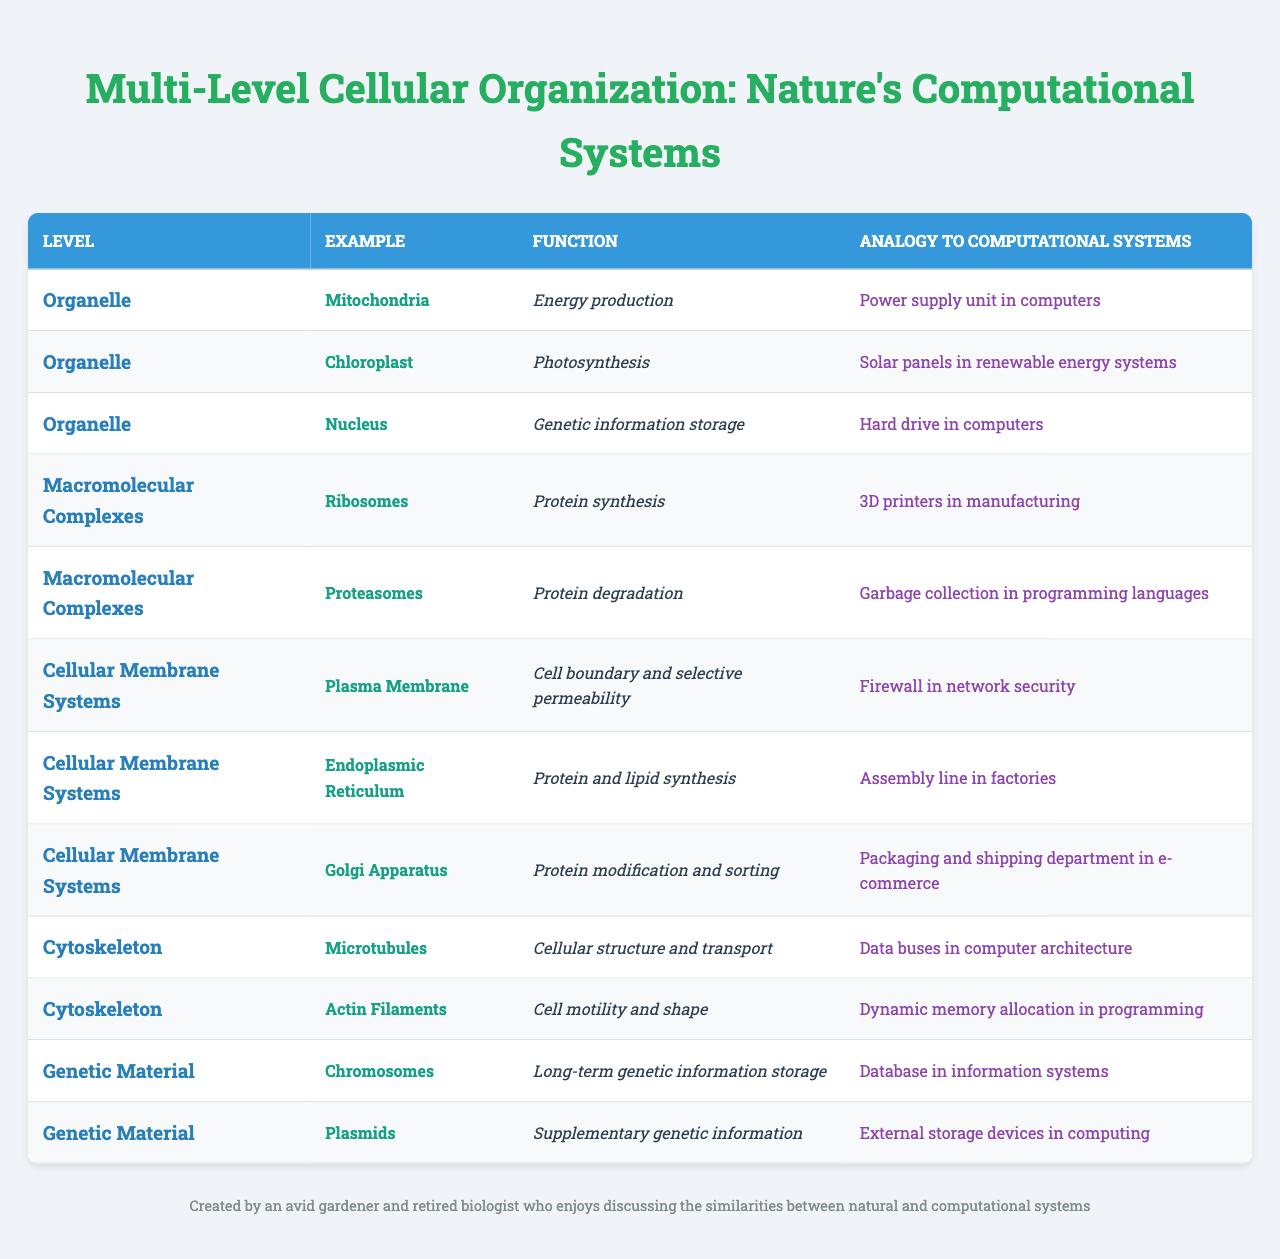What is the function of Ribosomes? Ribosomes are responsible for protein synthesis, as indicated in the table under the macromolecular complexes level.
Answer: Protein synthesis What analogy is used to describe the Chloroplast? The table indicates that Chloroplasts are likened to solar panels in renewable energy systems, which reflects their role in photosynthesis.
Answer: Solar panels in renewable energy systems Are Proteasomes involved in energy production? According to the table, Proteasomes are responsible for protein degradation, not energy production. Therefore, the answer is no.
Answer: No Which cellular structure is compared to a database? The table shows that Chromosomes serve a long-term genetic information storage function and are compared to a database in information systems.
Answer: Chromosomes What two functions are associated with the Endoplasmic Reticulum? The Endoplasmic Reticulum is associated with protein and lipid synthesis, as listed under the cellular membrane systems section in the table.
Answer: Protein and lipid synthesis How many examples are provided under the Organelle level? The Organelle level features three examples: Mitochondria, Chloroplast, and Nucleus, thus there are three examples in total.
Answer: Three What structure is analogous to a packaging and shipping department? The Golgi Apparatus is compared to a packaging and shipping department in the e-commerce analogy, as seen in the cellular membrane systems section of the table.
Answer: Golgi Apparatus Is there a structure related to cell shape and motility? Yes, Actin Filaments are specifically mentioned as involved in cell motility and shape within the cytoskeleton level of the table.
Answer: Yes Can you identify the structure responsible for genetic information storage? The Nucleus is identified in the table as the organelle responsible for genetic information storage, categorized under the Organelle level.
Answer: Nucleus What is the function of the Plasma Membrane? The Plasma Membrane serves as a cell boundary and provides selective permeability, according to the table in the cellular membrane systems section.
Answer: Cell boundary and selective permeability Which example has an analogy related to garbage collection? The Proteasomes are compared to garbage collection in programming languages, as mentioned under the macromolecular complexes level in the table.
Answer: Proteasomes 